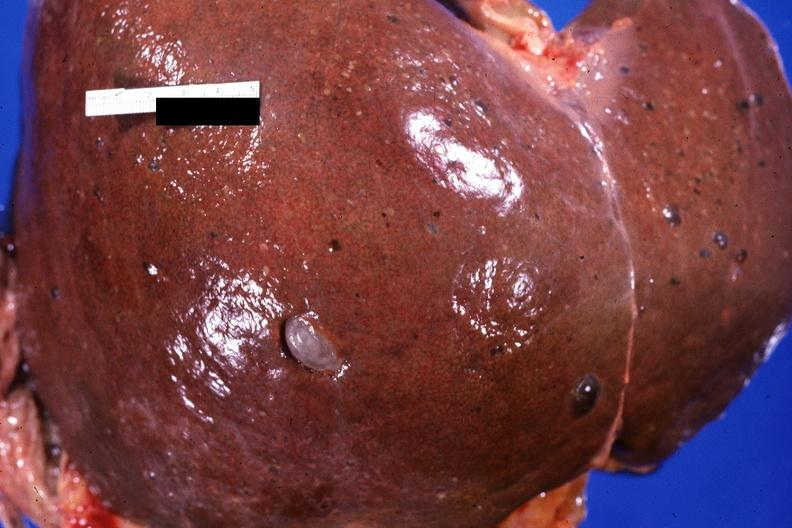what is present?
Answer the question using a single word or phrase. Hepatobiliary 